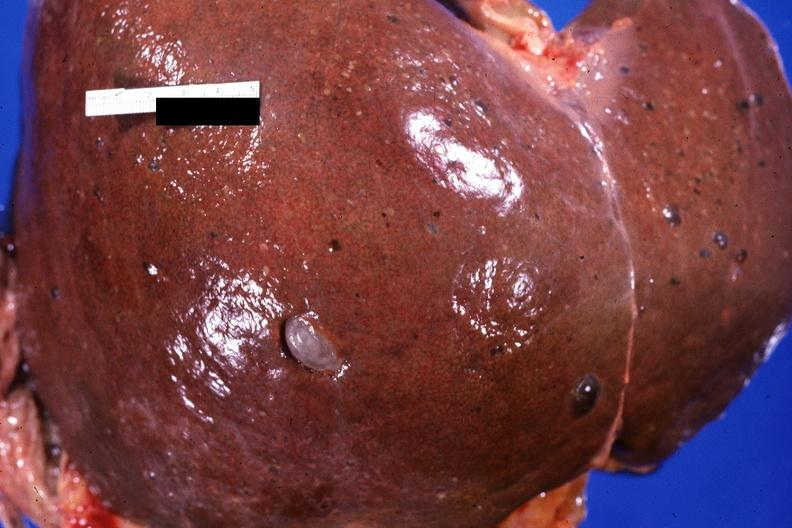what is present?
Answer the question using a single word or phrase. Hepatobiliary 